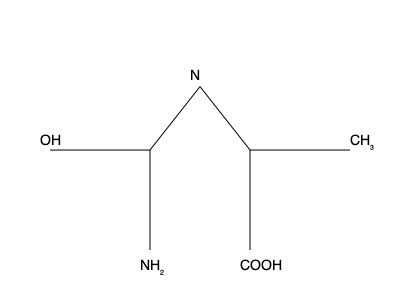Based on the molecular structure shown, what is the IUPAC name of this organic compound? To determine the IUPAC name of this organic compound, we'll follow these steps:

1. Identify the parent chain:
   The longest carbon chain is a 5-carbon chain, making it a pentane derivative.

2. Identify the highest priority functional group:
   The carboxylic acid (-COOH) group has the highest priority, so the suffix will be "-oic acid".

3. Number the carbon atoms:
   Start numbering from the carboxylic acid end, making it carbon 1.

4. Identify and name substituents:
   - An amino (-NH₂) group on carbon 2
   - A hydroxyl (-OH) group on carbon 5
   - A methyl (-CH₃) group on carbon 5

5. Identify the nitrogen-containing heterocycle:
   There's a nitrogen atom between carbons 3 and 4, forming an aziridine ring.

6. Combine all elements to form the name:
   - Parent chain: pentanoic acid
   - Substituents: 2-amino-5-hydroxy-5-methyl
   - Heterocycle: 3,4-aziridine

Therefore, the IUPAC name is: 2-amino-5-hydroxy-5-methyl-3,4-aziridinepentanoic acid
Answer: 2-amino-5-hydroxy-5-methyl-3,4-aziridinepentanoic acid 